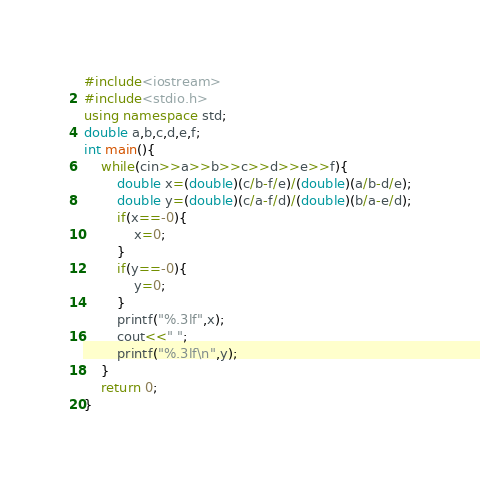<code> <loc_0><loc_0><loc_500><loc_500><_C++_>#include<iostream>
#include<stdio.h>
using namespace std;
double a,b,c,d,e,f;
int main(){
	while(cin>>a>>b>>c>>d>>e>>f){
		double x=(double)(c/b-f/e)/(double)(a/b-d/e);
		double y=(double)(c/a-f/d)/(double)(b/a-e/d);
		if(x==-0){
			x=0;
		}
		if(y==-0){
			y=0;
		}	
		printf("%.3lf",x);
		cout<<" ";
		printf("%.3lf\n",y);
	}
	return 0;
}	
</code> 